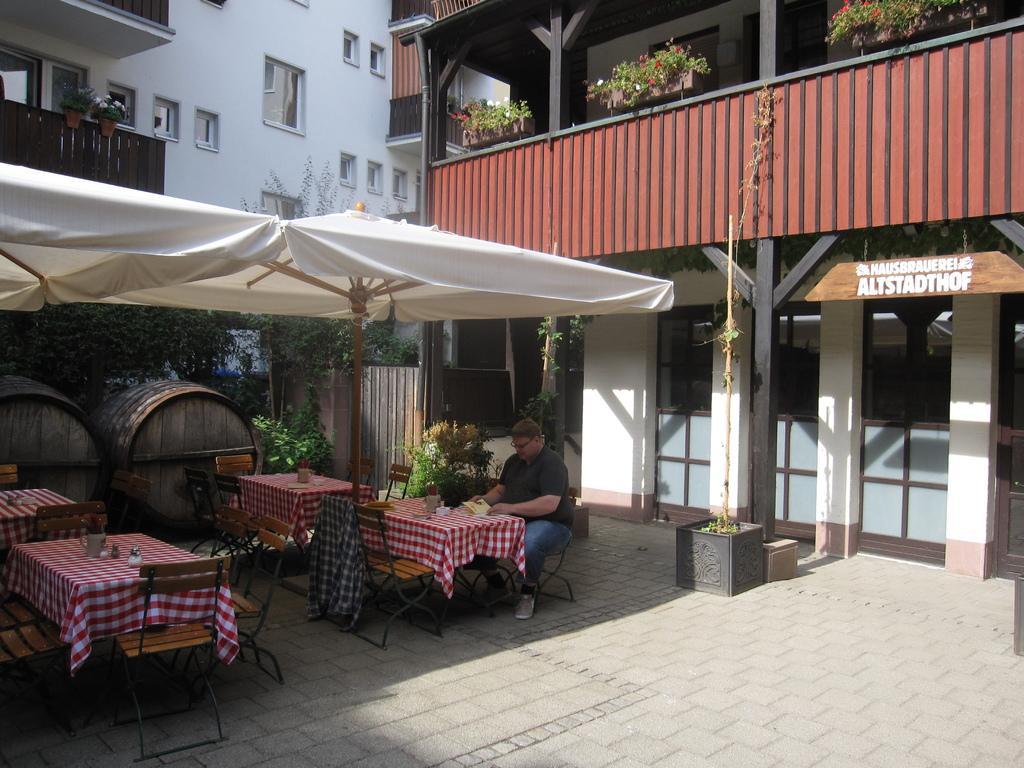Could you give a brief overview of what you see in this image? In this picture we can see a man sitting on a chair, umbrellas, barrels, chairs, tables on the floor with clothes, cups, jars, cards on it, trees, house plants, name board and some objects and in the background we can see buildings with windows. 